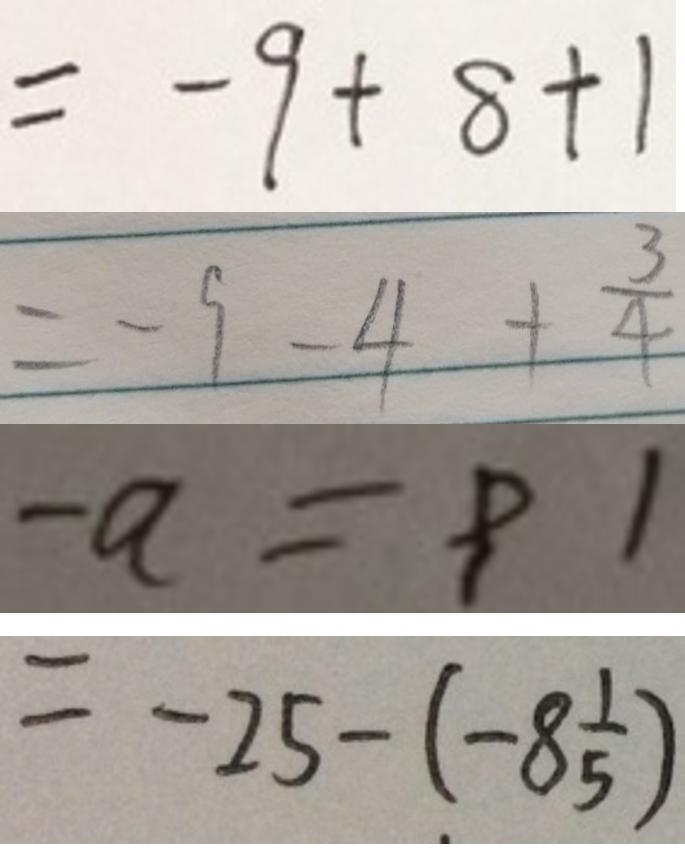Convert formula to latex. <formula><loc_0><loc_0><loc_500><loc_500>= - 9 + 8 + 1 
 = - 9 - 4 + \frac { 3 } { 4 } 
 - a = 9 1 
 = - 2 5 - ( - 8 \frac { 1 } { 5 } )</formula> 